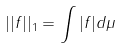<formula> <loc_0><loc_0><loc_500><loc_500>| | f | | _ { 1 } = \int | f | d \mu</formula> 